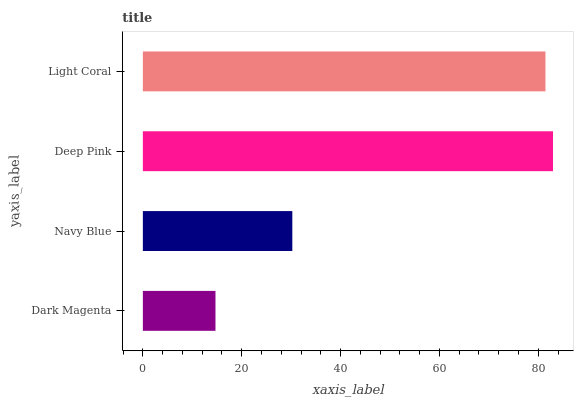Is Dark Magenta the minimum?
Answer yes or no. Yes. Is Deep Pink the maximum?
Answer yes or no. Yes. Is Navy Blue the minimum?
Answer yes or no. No. Is Navy Blue the maximum?
Answer yes or no. No. Is Navy Blue greater than Dark Magenta?
Answer yes or no. Yes. Is Dark Magenta less than Navy Blue?
Answer yes or no. Yes. Is Dark Magenta greater than Navy Blue?
Answer yes or no. No. Is Navy Blue less than Dark Magenta?
Answer yes or no. No. Is Light Coral the high median?
Answer yes or no. Yes. Is Navy Blue the low median?
Answer yes or no. Yes. Is Deep Pink the high median?
Answer yes or no. No. Is Dark Magenta the low median?
Answer yes or no. No. 